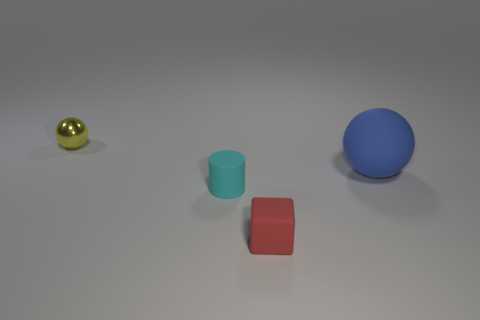Add 2 red things. How many objects exist? 6 Subtract all yellow spheres. How many spheres are left? 1 Subtract all cubes. How many objects are left? 3 Subtract all purple balls. Subtract all tiny shiny things. How many objects are left? 3 Add 1 red rubber objects. How many red rubber objects are left? 2 Add 4 tiny green objects. How many tiny green objects exist? 4 Subtract 0 purple cubes. How many objects are left? 4 Subtract 2 spheres. How many spheres are left? 0 Subtract all yellow blocks. Subtract all gray cylinders. How many blocks are left? 1 